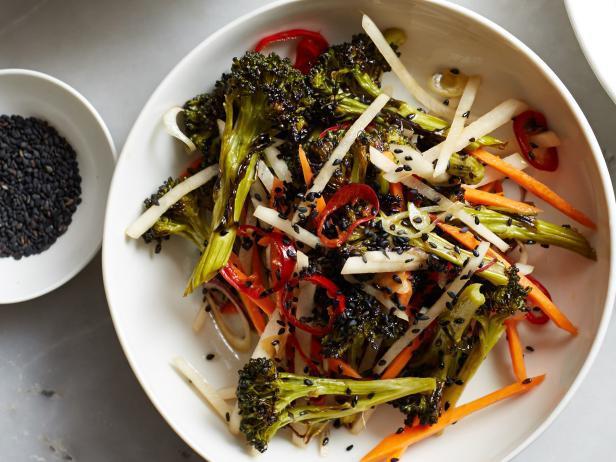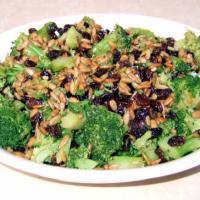The first image is the image on the left, the second image is the image on the right. Evaluate the accuracy of this statement regarding the images: "One image shows a piece of silverware on the edge of a round white handle-less dish containing broccoli florets.". Is it true? Answer yes or no. No. 